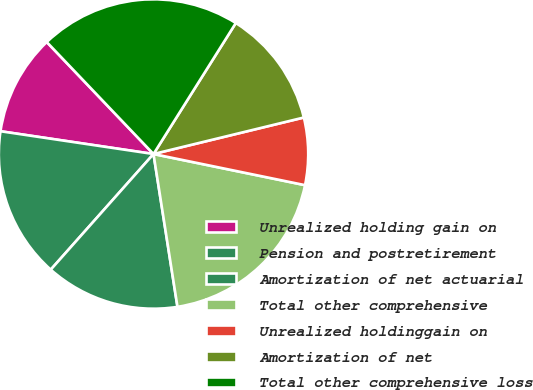<chart> <loc_0><loc_0><loc_500><loc_500><pie_chart><fcel>Unrealized holding gain on<fcel>Pension and postretirement<fcel>Amortization of net actuarial<fcel>Total other comprehensive<fcel>Unrealized holdinggain on<fcel>Amortization of net<fcel>Total other comprehensive loss<nl><fcel>10.53%<fcel>15.79%<fcel>14.04%<fcel>19.3%<fcel>7.02%<fcel>12.28%<fcel>21.05%<nl></chart> 